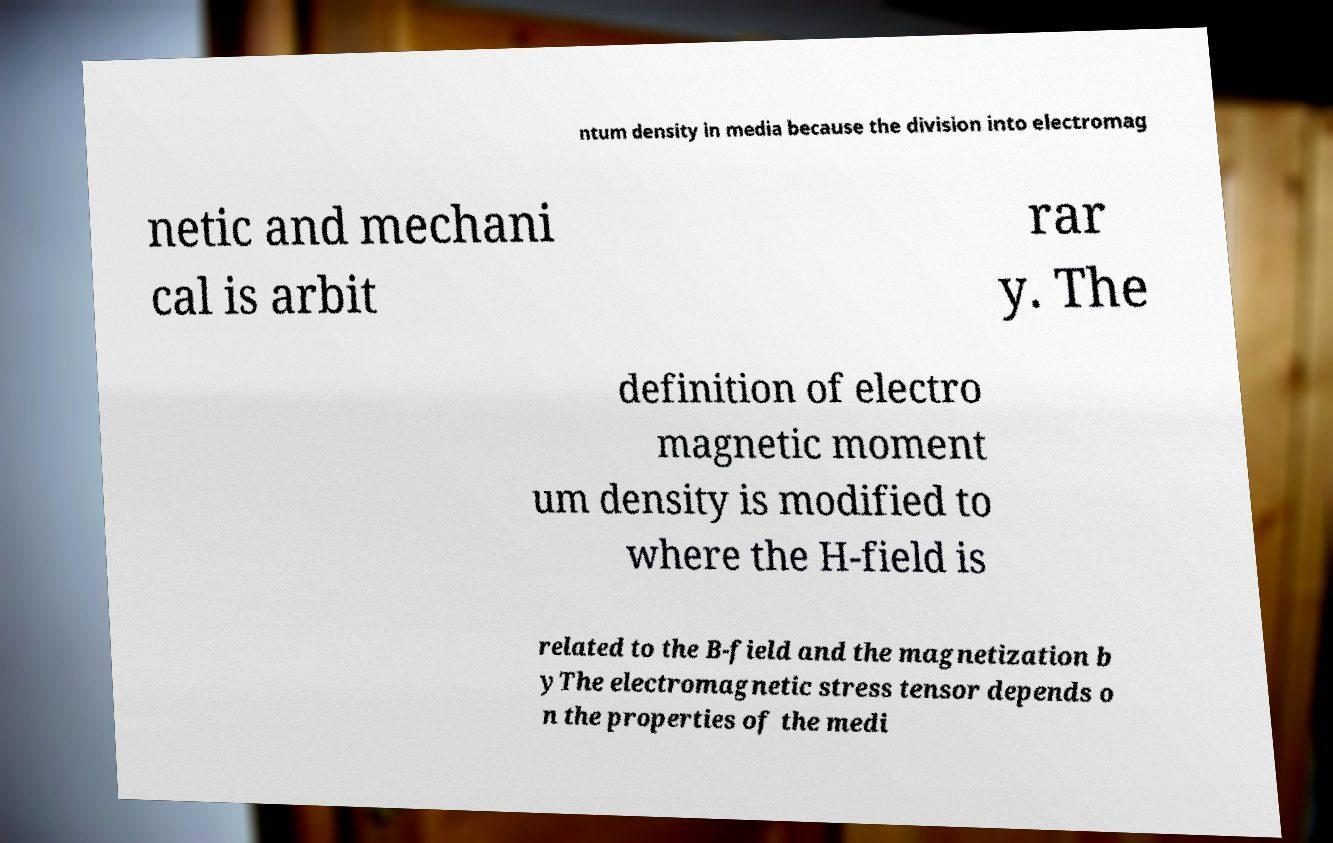Can you accurately transcribe the text from the provided image for me? ntum density in media because the division into electromag netic and mechani cal is arbit rar y. The definition of electro magnetic moment um density is modified to where the H-field is related to the B-field and the magnetization b yThe electromagnetic stress tensor depends o n the properties of the medi 